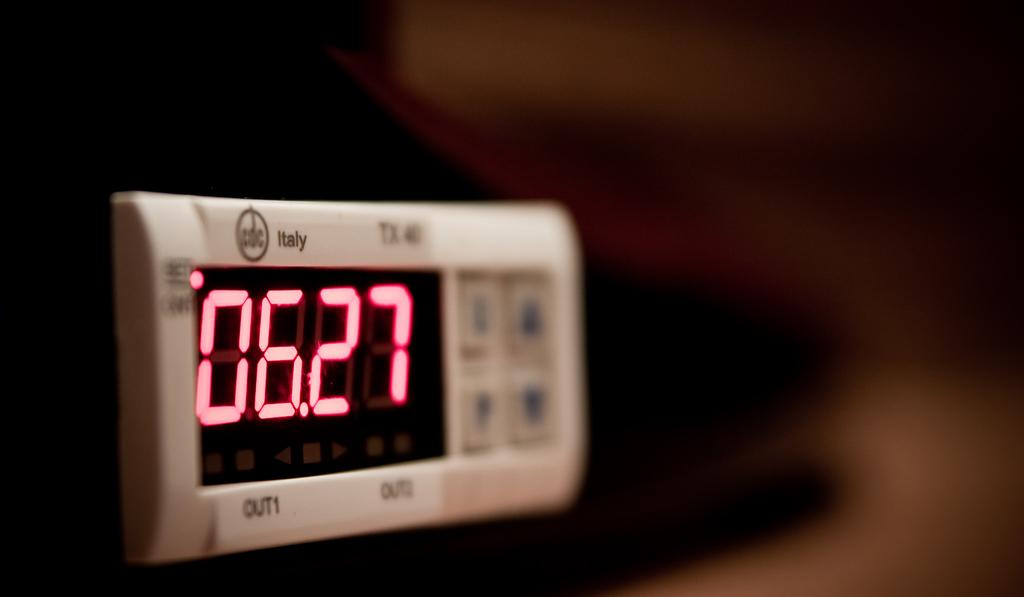<image>
Write a terse but informative summary of the picture. An Italy clock has the time 06.27 on it's screen. 